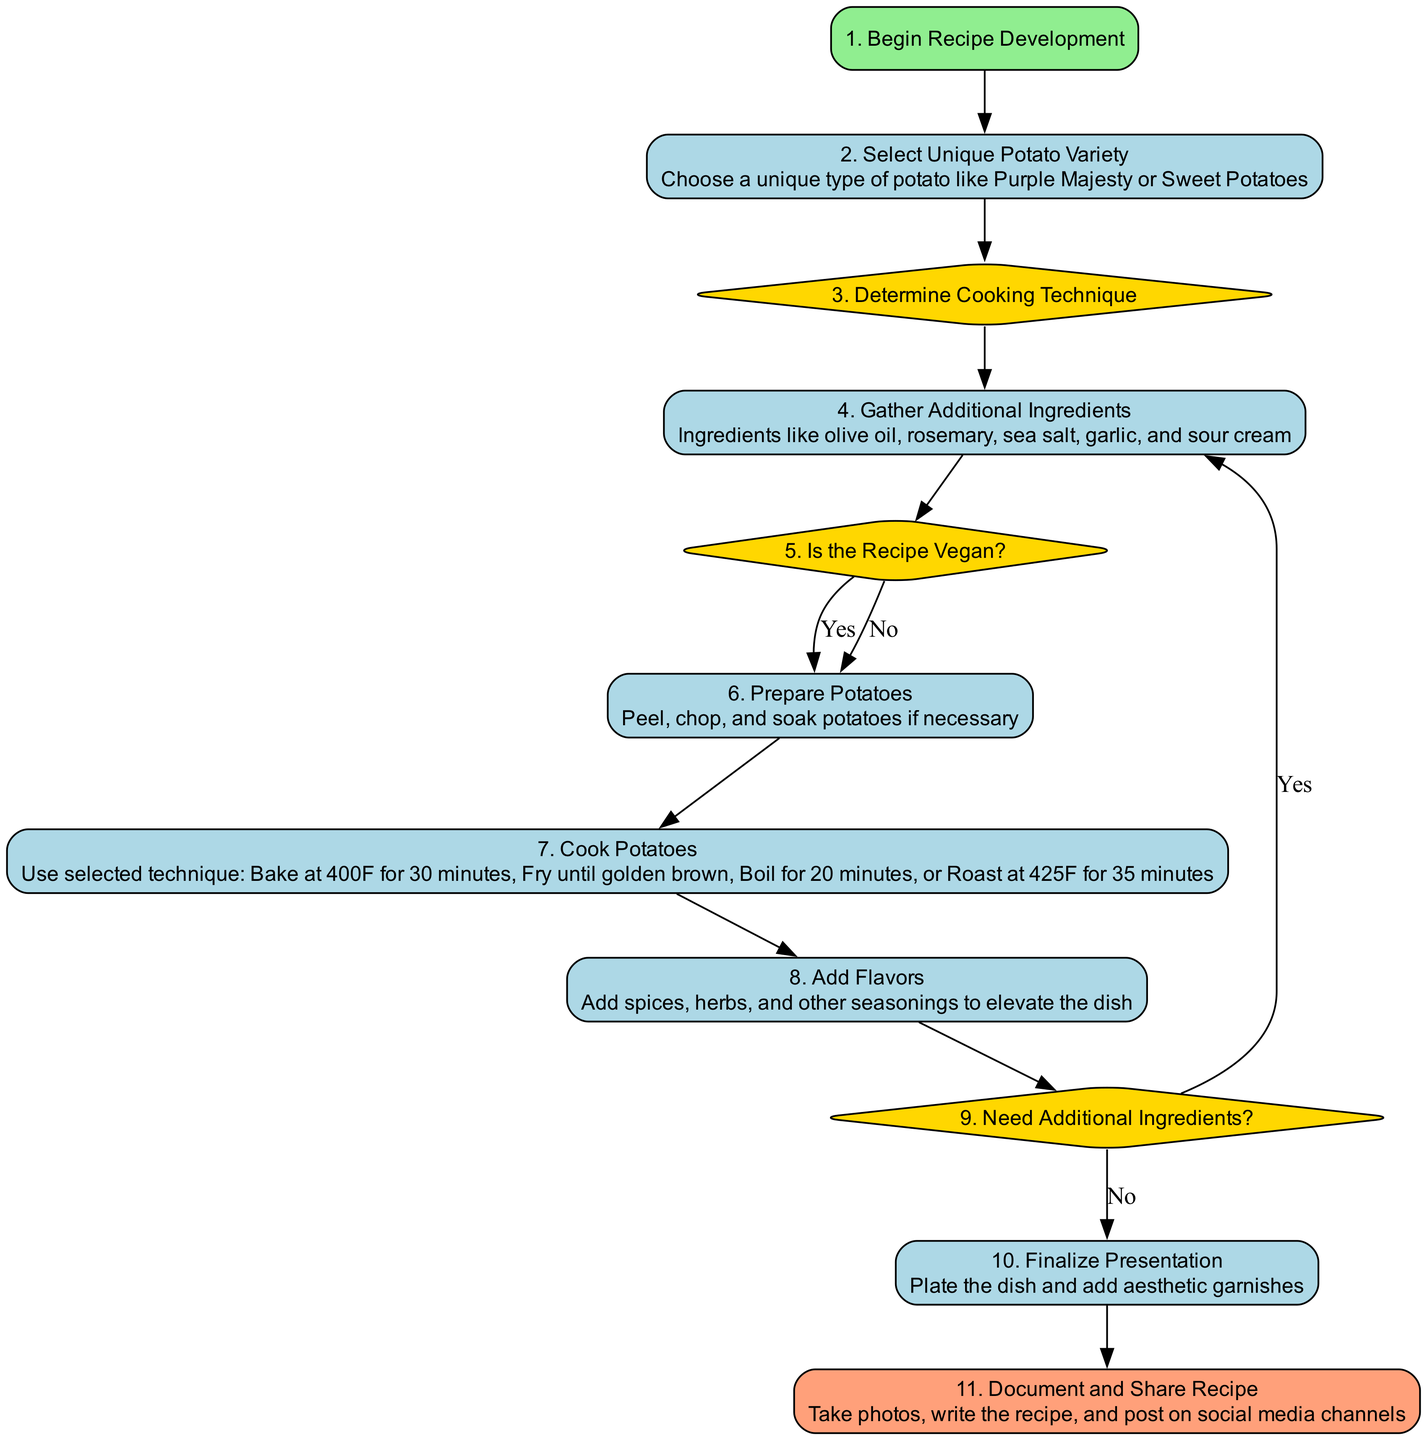What's the first step in the recipe development process? The first step in the flowchart is labeled "Begin Recipe Development," which is step 1 in the sequence.
Answer: Begin Recipe Development How many decision nodes are in the diagram? The diagram includes three decision nodes: "Determine Cooking Technique," "Is the Recipe Vegan?", and "Need Additional Ingredients?". Counting these gives us three decision nodes.
Answer: Three What are the final actions taken in the recipe development? The last step in the flowchart is "Document and Share Recipe," which involves taking photos, writing the recipe, and posting on social media. This indicates the final actions taken.
Answer: Document and Share Recipe What will happen if the answer to "Is the Recipe Vegan?" is "No"? If the answer is "No," the flow proceeds directly to the "Prepare Potatoes" step without returning to gather additional ingredients. This shows that both options (Yes and No) lead to the same subsequent step.
Answer: Prepare Potatoes What is one of the unique potato varieties suggested? The flowchart suggests options like "Purple Majesty" or "Sweet Potatoes," so one example would be "Purple Majesty."
Answer: Purple Majesty If additional ingredients are needed, where does the flow return to? If additional ingredients are necessary, the flowchart indicates that it returns to "Gather Additional Ingredients," allowing for the possibility of adding more components to the dish.
Answer: Gather Additional Ingredients What is the cooking time for baking potatoes? The flowchart specifies a cooking time of "30 minutes" when baking potatoes at 400 degrees Fahrenheit. This precise detail indicates the required time for this cooking method.
Answer: 30 minutes What type of node represents the action of "Add Flavors"? The action "Add Flavors" is categorized as a process node, indicating that it requires specific steps/actions to elevate the dish through seasoning.
Answer: Process What happens after final presentation in the flow? After the "Finalize Presentation" step, the next action is to document and share the recipe, showing the progression from plating to sharing.
Answer: Document and Share Recipe 